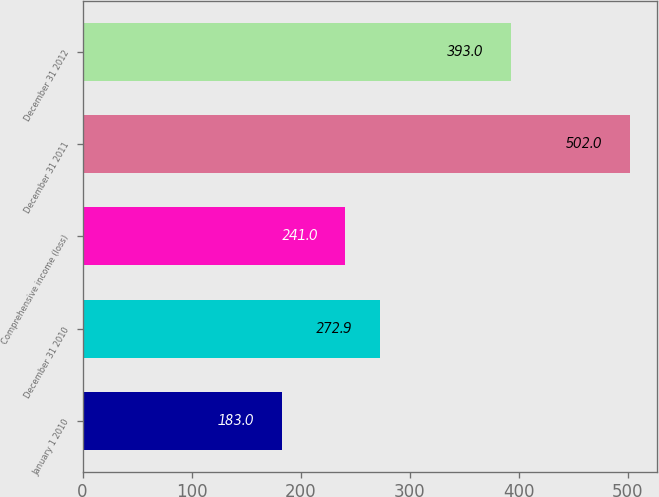<chart> <loc_0><loc_0><loc_500><loc_500><bar_chart><fcel>January 1 2010<fcel>December 31 2010<fcel>Comprehensive income (loss)<fcel>December 31 2011<fcel>December 31 2012<nl><fcel>183<fcel>272.9<fcel>241<fcel>502<fcel>393<nl></chart> 